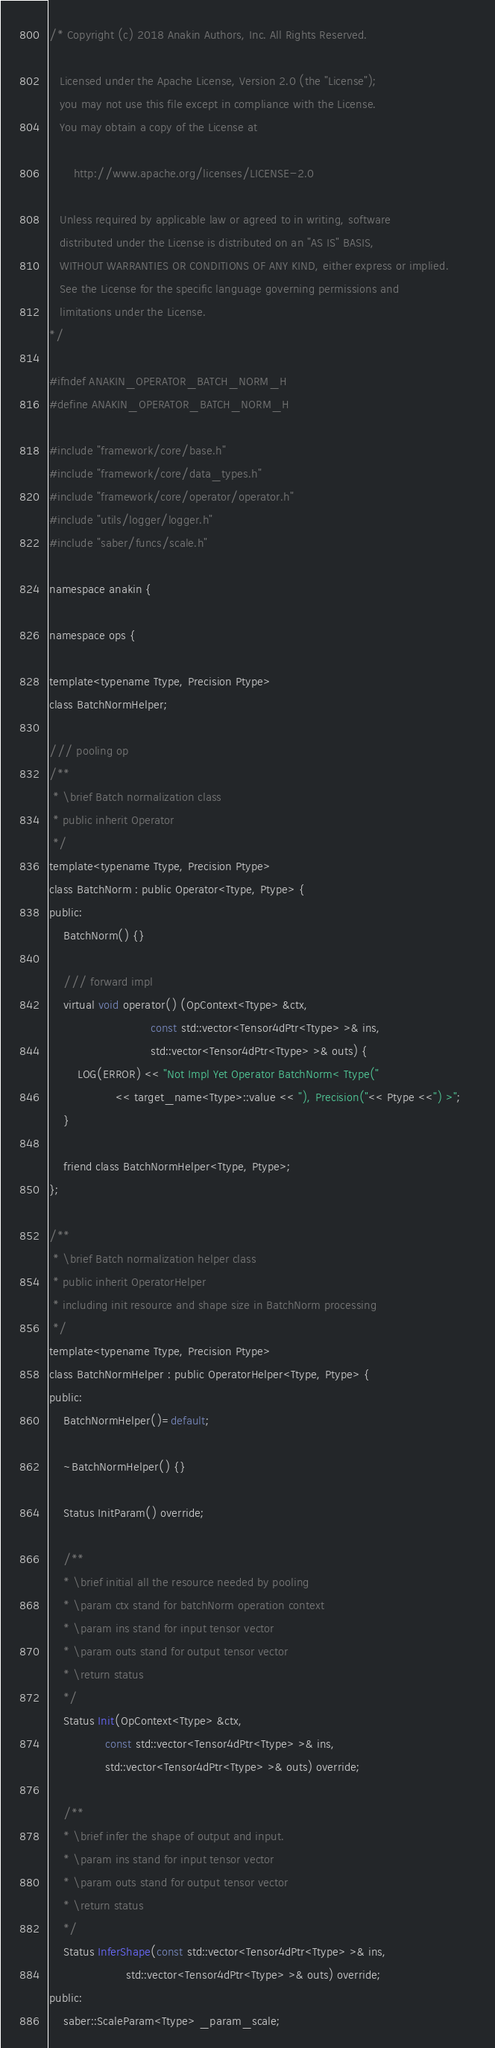<code> <loc_0><loc_0><loc_500><loc_500><_C_>/* Copyright (c) 2018 Anakin Authors, Inc. All Rights Reserved.

   Licensed under the Apache License, Version 2.0 (the "License");
   you may not use this file except in compliance with the License.
   You may obtain a copy of the License at

       http://www.apache.org/licenses/LICENSE-2.0
   
   Unless required by applicable law or agreed to in writing, software
   distributed under the License is distributed on an "AS IS" BASIS,
   WITHOUT WARRANTIES OR CONDITIONS OF ANY KIND, either express or implied.
   See the License for the specific language governing permissions and
   limitations under the License. 
*/

#ifndef ANAKIN_OPERATOR_BATCH_NORM_H
#define ANAKIN_OPERATOR_BATCH_NORM_H

#include "framework/core/base.h"
#include "framework/core/data_types.h"
#include "framework/core/operator/operator.h"
#include "utils/logger/logger.h"
#include "saber/funcs/scale.h"

namespace anakin {

namespace ops {

template<typename Ttype, Precision Ptype>
class BatchNormHelper;

/// pooling op
/**
 * \brief Batch normalization class
 * public inherit Operator
 */
template<typename Ttype, Precision Ptype>
class BatchNorm : public Operator<Ttype, Ptype> {
public:
    BatchNorm() {}

    /// forward impl
    virtual void operator() (OpContext<Ttype> &ctx, 
                             const std::vector<Tensor4dPtr<Ttype> >& ins, 
                             std::vector<Tensor4dPtr<Ttype> >& outs) {
		LOG(ERROR) << "Not Impl Yet Operator BatchNorm< Ttype("
                   << target_name<Ttype>::value << "), Precision("<< Ptype <<") >";	
    }

    friend class BatchNormHelper<Ttype, Ptype>;
};

/**
 * \brief Batch normalization helper class
 * public inherit OperatorHelper
 * including init resource and shape size in BatchNorm processing
 */
template<typename Ttype, Precision Ptype>
class BatchNormHelper : public OperatorHelper<Ttype, Ptype> {
public:
    BatchNormHelper()=default;

    ~BatchNormHelper() {}

    Status InitParam() override;

    /**
    * \brief initial all the resource needed by pooling
    * \param ctx stand for batchNorm operation context
    * \param ins stand for input tensor vector
    * \param outs stand for output tensor vector
    * \return status
    */
    Status Init(OpContext<Ttype> &ctx,
                const std::vector<Tensor4dPtr<Ttype> >& ins, 
                std::vector<Tensor4dPtr<Ttype> >& outs) override;

    /**
    * \brief infer the shape of output and input.
    * \param ins stand for input tensor vector
    * \param outs stand for output tensor vector
    * \return status
    */
    Status InferShape(const std::vector<Tensor4dPtr<Ttype> >& ins,
                      std::vector<Tensor4dPtr<Ttype> >& outs) override;
public:
    saber::ScaleParam<Ttype> _param_scale;</code> 